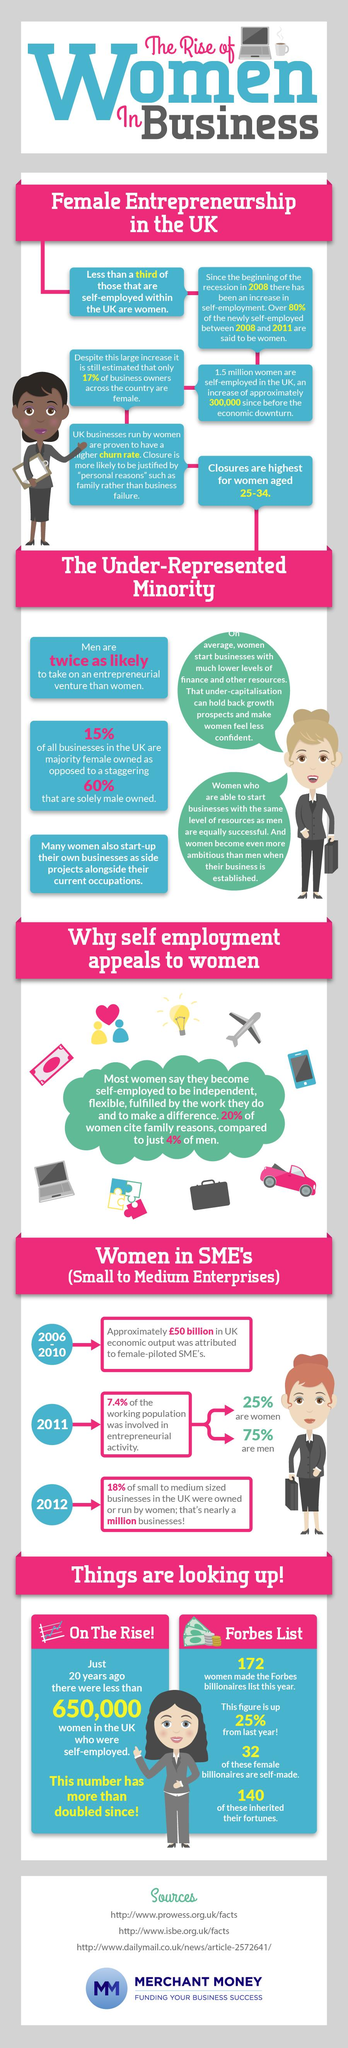Specify some key components in this picture. In 2011, statistics show that only 25% of the working population in the UK involved in entrepreneurial activity are women. 